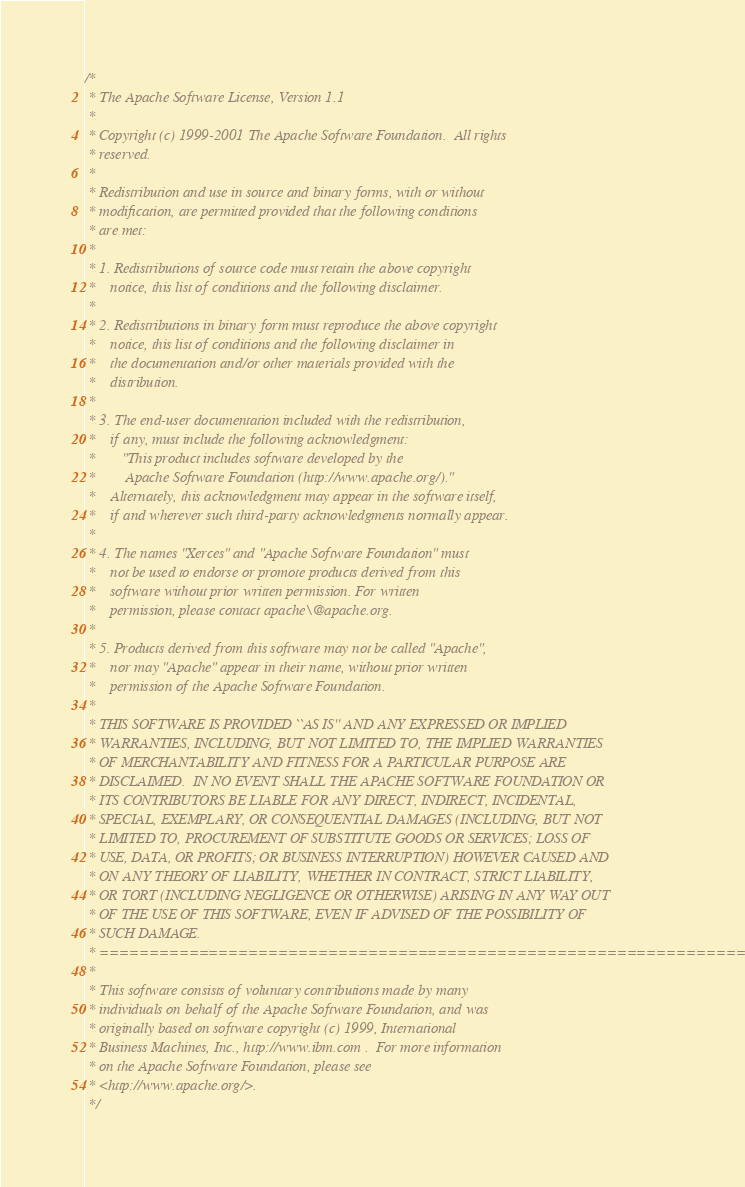Convert code to text. <code><loc_0><loc_0><loc_500><loc_500><_C++_>/*
 * The Apache Software License, Version 1.1
 *
 * Copyright (c) 1999-2001 The Apache Software Foundation.  All rights
 * reserved.
 *
 * Redistribution and use in source and binary forms, with or without
 * modification, are permitted provided that the following conditions
 * are met:
 *
 * 1. Redistributions of source code must retain the above copyright
 *    notice, this list of conditions and the following disclaimer.
 *
 * 2. Redistributions in binary form must reproduce the above copyright
 *    notice, this list of conditions and the following disclaimer in
 *    the documentation and/or other materials provided with the
 *    distribution.
 *
 * 3. The end-user documentation included with the redistribution,
 *    if any, must include the following acknowledgment:
 *       "This product includes software developed by the
 *        Apache Software Foundation (http://www.apache.org/)."
 *    Alternately, this acknowledgment may appear in the software itself,
 *    if and wherever such third-party acknowledgments normally appear.
 *
 * 4. The names "Xerces" and "Apache Software Foundation" must
 *    not be used to endorse or promote products derived from this
 *    software without prior written permission. For written
 *    permission, please contact apache\@apache.org.
 *
 * 5. Products derived from this software may not be called "Apache",
 *    nor may "Apache" appear in their name, without prior written
 *    permission of the Apache Software Foundation.
 *
 * THIS SOFTWARE IS PROVIDED ``AS IS'' AND ANY EXPRESSED OR IMPLIED
 * WARRANTIES, INCLUDING, BUT NOT LIMITED TO, THE IMPLIED WARRANTIES
 * OF MERCHANTABILITY AND FITNESS FOR A PARTICULAR PURPOSE ARE
 * DISCLAIMED.  IN NO EVENT SHALL THE APACHE SOFTWARE FOUNDATION OR
 * ITS CONTRIBUTORS BE LIABLE FOR ANY DIRECT, INDIRECT, INCIDENTAL,
 * SPECIAL, EXEMPLARY, OR CONSEQUENTIAL DAMAGES (INCLUDING, BUT NOT
 * LIMITED TO, PROCUREMENT OF SUBSTITUTE GOODS OR SERVICES; LOSS OF
 * USE, DATA, OR PROFITS; OR BUSINESS INTERRUPTION) HOWEVER CAUSED AND
 * ON ANY THEORY OF LIABILITY, WHETHER IN CONTRACT, STRICT LIABILITY,
 * OR TORT (INCLUDING NEGLIGENCE OR OTHERWISE) ARISING IN ANY WAY OUT
 * OF THE USE OF THIS SOFTWARE, EVEN IF ADVISED OF THE POSSIBILITY OF
 * SUCH DAMAGE.
 * ====================================================================
 *
 * This software consists of voluntary contributions made by many
 * individuals on behalf of the Apache Software Foundation, and was
 * originally based on software copyright (c) 1999, International
 * Business Machines, Inc., http://www.ibm.com .  For more information
 * on the Apache Software Foundation, please see
 * <http://www.apache.org/>.
 */</code> 